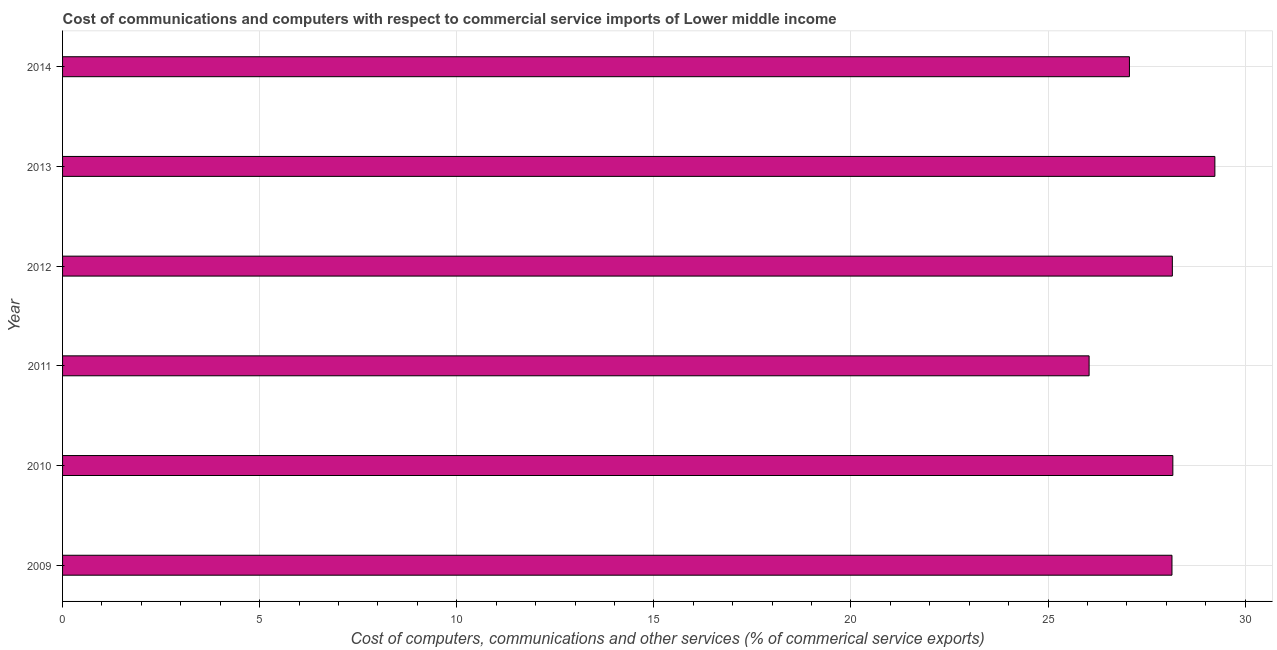What is the title of the graph?
Give a very brief answer. Cost of communications and computers with respect to commercial service imports of Lower middle income. What is the label or title of the X-axis?
Provide a succinct answer. Cost of computers, communications and other services (% of commerical service exports). What is the cost of communications in 2009?
Offer a very short reply. 28.14. Across all years, what is the maximum  computer and other services?
Provide a succinct answer. 29.23. Across all years, what is the minimum  computer and other services?
Your answer should be compact. 26.04. In which year was the cost of communications minimum?
Ensure brevity in your answer.  2011. What is the sum of the  computer and other services?
Ensure brevity in your answer.  166.8. What is the difference between the cost of communications in 2010 and 2014?
Offer a very short reply. 1.1. What is the average cost of communications per year?
Provide a short and direct response. 27.8. What is the median cost of communications?
Your answer should be very brief. 28.15. In how many years, is the cost of communications greater than 4 %?
Your answer should be very brief. 6. Do a majority of the years between 2009 and 2011 (inclusive) have cost of communications greater than 16 %?
Provide a succinct answer. Yes. What is the ratio of the cost of communications in 2010 to that in 2011?
Your answer should be compact. 1.08. What is the difference between the highest and the second highest cost of communications?
Your answer should be compact. 1.07. Is the sum of the  computer and other services in 2012 and 2013 greater than the maximum  computer and other services across all years?
Provide a short and direct response. Yes. What is the difference between the highest and the lowest cost of communications?
Your answer should be compact. 3.19. How many bars are there?
Keep it short and to the point. 6. What is the difference between two consecutive major ticks on the X-axis?
Provide a short and direct response. 5. Are the values on the major ticks of X-axis written in scientific E-notation?
Give a very brief answer. No. What is the Cost of computers, communications and other services (% of commerical service exports) in 2009?
Make the answer very short. 28.14. What is the Cost of computers, communications and other services (% of commerical service exports) in 2010?
Your answer should be very brief. 28.17. What is the Cost of computers, communications and other services (% of commerical service exports) in 2011?
Provide a succinct answer. 26.04. What is the Cost of computers, communications and other services (% of commerical service exports) of 2012?
Make the answer very short. 28.15. What is the Cost of computers, communications and other services (% of commerical service exports) in 2013?
Ensure brevity in your answer.  29.23. What is the Cost of computers, communications and other services (% of commerical service exports) in 2014?
Your answer should be very brief. 27.07. What is the difference between the Cost of computers, communications and other services (% of commerical service exports) in 2009 and 2010?
Provide a short and direct response. -0.02. What is the difference between the Cost of computers, communications and other services (% of commerical service exports) in 2009 and 2011?
Give a very brief answer. 2.1. What is the difference between the Cost of computers, communications and other services (% of commerical service exports) in 2009 and 2012?
Your response must be concise. -0.01. What is the difference between the Cost of computers, communications and other services (% of commerical service exports) in 2009 and 2013?
Provide a succinct answer. -1.09. What is the difference between the Cost of computers, communications and other services (% of commerical service exports) in 2009 and 2014?
Your answer should be compact. 1.08. What is the difference between the Cost of computers, communications and other services (% of commerical service exports) in 2010 and 2011?
Give a very brief answer. 2.12. What is the difference between the Cost of computers, communications and other services (% of commerical service exports) in 2010 and 2012?
Give a very brief answer. 0.01. What is the difference between the Cost of computers, communications and other services (% of commerical service exports) in 2010 and 2013?
Provide a succinct answer. -1.07. What is the difference between the Cost of computers, communications and other services (% of commerical service exports) in 2010 and 2014?
Your answer should be compact. 1.1. What is the difference between the Cost of computers, communications and other services (% of commerical service exports) in 2011 and 2012?
Keep it short and to the point. -2.11. What is the difference between the Cost of computers, communications and other services (% of commerical service exports) in 2011 and 2013?
Offer a terse response. -3.19. What is the difference between the Cost of computers, communications and other services (% of commerical service exports) in 2011 and 2014?
Offer a terse response. -1.02. What is the difference between the Cost of computers, communications and other services (% of commerical service exports) in 2012 and 2013?
Offer a very short reply. -1.08. What is the difference between the Cost of computers, communications and other services (% of commerical service exports) in 2012 and 2014?
Give a very brief answer. 1.09. What is the difference between the Cost of computers, communications and other services (% of commerical service exports) in 2013 and 2014?
Ensure brevity in your answer.  2.17. What is the ratio of the Cost of computers, communications and other services (% of commerical service exports) in 2009 to that in 2011?
Offer a terse response. 1.08. What is the ratio of the Cost of computers, communications and other services (% of commerical service exports) in 2009 to that in 2013?
Make the answer very short. 0.96. What is the ratio of the Cost of computers, communications and other services (% of commerical service exports) in 2009 to that in 2014?
Offer a very short reply. 1.04. What is the ratio of the Cost of computers, communications and other services (% of commerical service exports) in 2010 to that in 2011?
Offer a very short reply. 1.08. What is the ratio of the Cost of computers, communications and other services (% of commerical service exports) in 2010 to that in 2012?
Provide a succinct answer. 1. What is the ratio of the Cost of computers, communications and other services (% of commerical service exports) in 2010 to that in 2014?
Make the answer very short. 1.04. What is the ratio of the Cost of computers, communications and other services (% of commerical service exports) in 2011 to that in 2012?
Your answer should be compact. 0.93. What is the ratio of the Cost of computers, communications and other services (% of commerical service exports) in 2011 to that in 2013?
Keep it short and to the point. 0.89. What is the ratio of the Cost of computers, communications and other services (% of commerical service exports) in 2012 to that in 2013?
Your response must be concise. 0.96. What is the ratio of the Cost of computers, communications and other services (% of commerical service exports) in 2012 to that in 2014?
Make the answer very short. 1.04. 